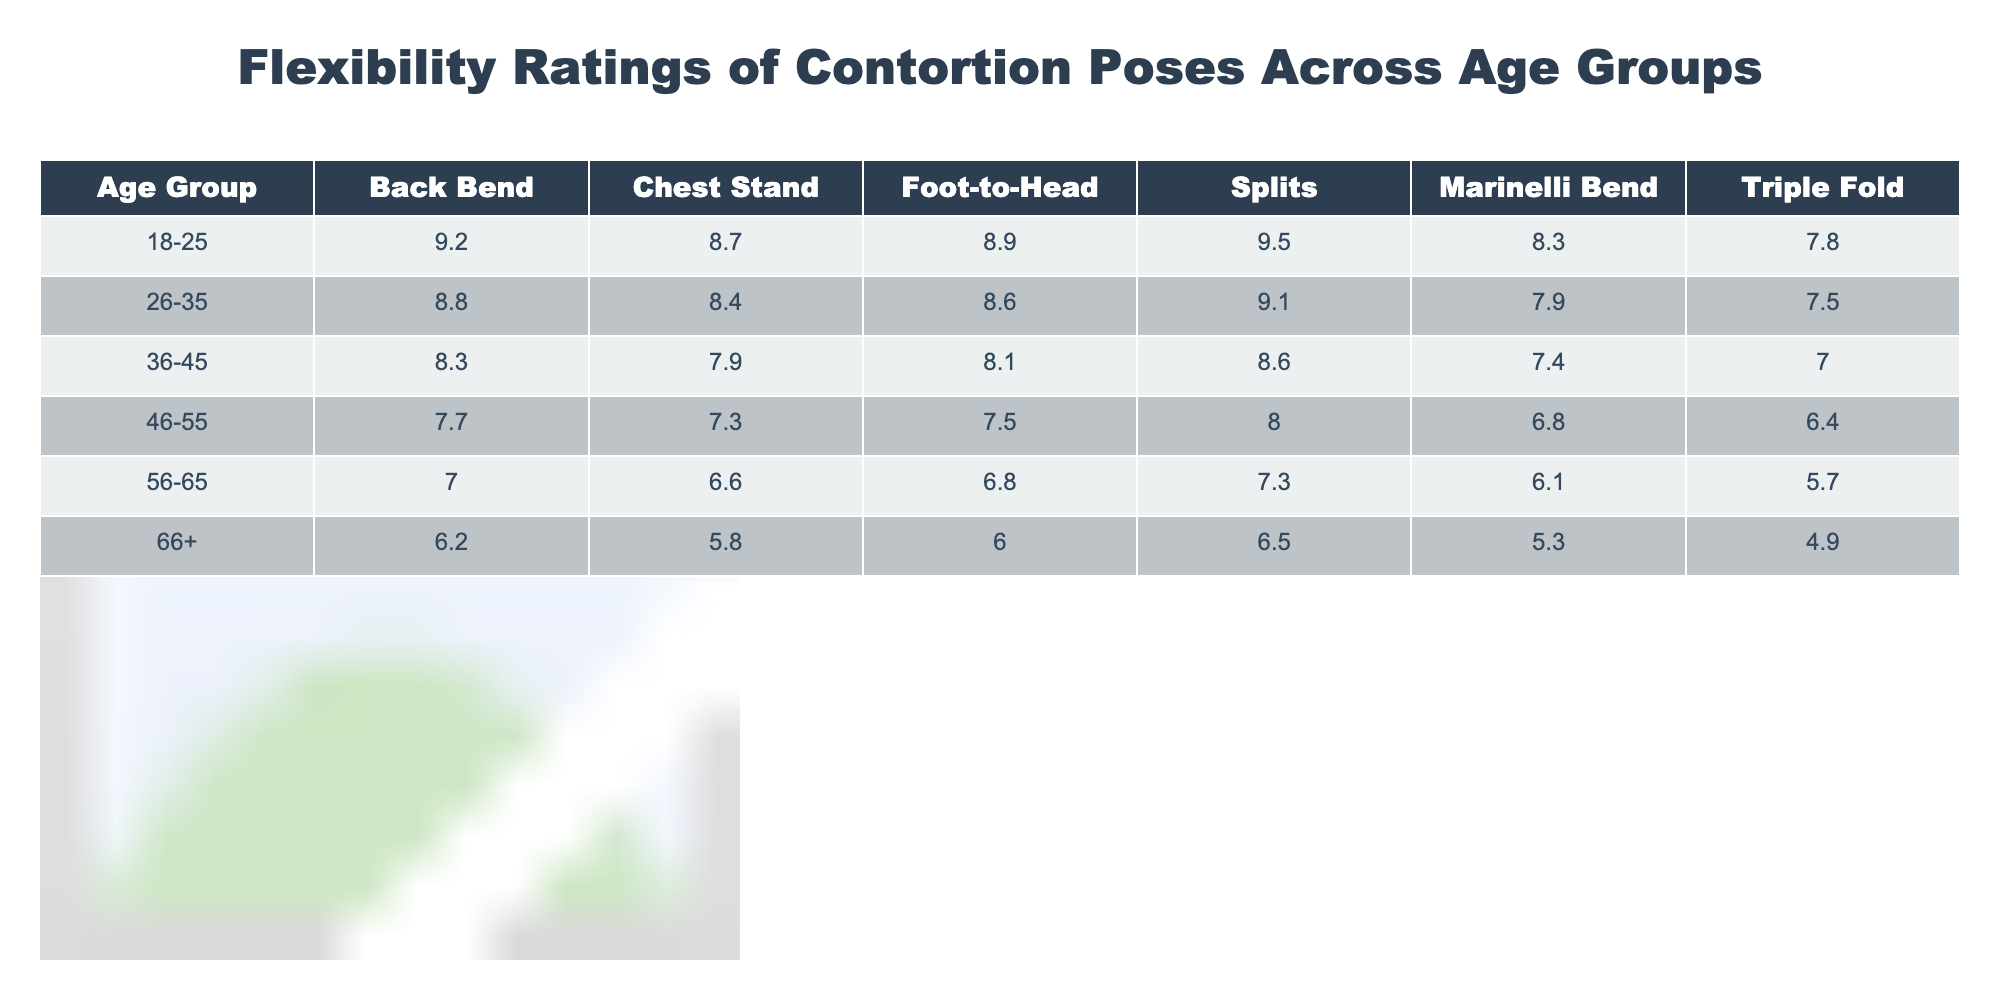What is the flexibility rating for the "Foot-to-Head" pose in the age group 36-45? The table shows that the flexibility rating for the "Foot-to-Head" pose in the age group 36-45 is 8.1.
Answer: 8.1 Which age group has the highest rating for the "Splits" pose? The highest rating for the "Splits" pose is 9.5, which belongs to the age group 18-25.
Answer: 18-25 What is the average flexibility rating for the "Chest Stand" pose across all age groups? To find the average, we sum the ratings: (8.7 + 8.4 + 7.9 + 7.3 + 6.6 + 5.8) = 44.7. The average is 44.7/6 = 7.45.
Answer: 7.45 Which age group has the lowest overall flexibility rating for all poses? The age group 66+ has the lowest ratings across all poses consistently, indicating a decrease in flexibility with age.
Answer: 66+ Is the flexibility rating for the "Triple Fold" pose higher for the age group 26-35 than for 46-55? The "Triple Fold" rating for 26-35 is 7.5, while for 46-55 it is 6.4, thus confirming that 7.5 is higher than 6.4.
Answer: Yes What is the difference in the rating for the "Back Bend" pose between the age groups 18-25 and 56-65? The "Back Bend" rating for 18-25 is 9.2 and for 56-65 is 7.0. The difference is 9.2 - 7.0 = 2.2.
Answer: 2.2 Which pose has the highest rating in the age group 46-55? In the age group 46-55, the highest rating is for the "Splits" pose with a flexibility rating of 8.0, which is higher than the other poses in that age group.
Answer: Splits If we consider the average ratings of all poses for the age group 36-45, what is the average? We sum the ratings: (8.3 + 7.9 + 8.1 + 8.6 + 7.4 + 7.0) = 47.3. The average is 47.3/6 = 7.883, rounding gives us approximately 7.88.
Answer: 7.88 Are the flexibility ratings for the "Marinelli Bend" pose in age groups 26-35 and 46-55 both above 7? The "Marinelli Bend" rating for 26-35 is 7.9 and for 46-55 is 6.8, so only the former is above 7.
Answer: No What can be said about the overall trend in flexibility ratings as age increases? As seen in the table, flexibility ratings generally decrease with increasing age across all poses, indicating a downward trend as age rises.
Answer: Decreasing trend 